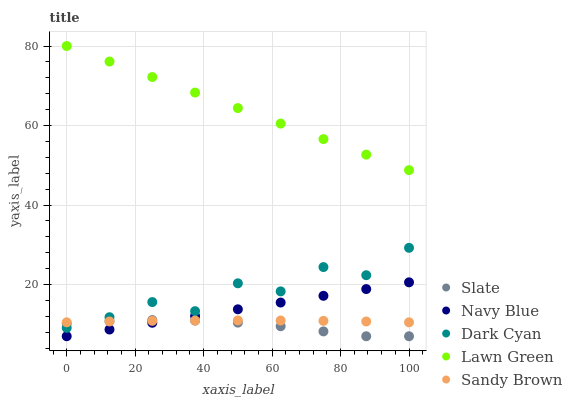Does Slate have the minimum area under the curve?
Answer yes or no. Yes. Does Lawn Green have the maximum area under the curve?
Answer yes or no. Yes. Does Navy Blue have the minimum area under the curve?
Answer yes or no. No. Does Navy Blue have the maximum area under the curve?
Answer yes or no. No. Is Navy Blue the smoothest?
Answer yes or no. Yes. Is Dark Cyan the roughest?
Answer yes or no. Yes. Is Slate the smoothest?
Answer yes or no. No. Is Slate the roughest?
Answer yes or no. No. Does Navy Blue have the lowest value?
Answer yes or no. Yes. Does Sandy Brown have the lowest value?
Answer yes or no. No. Does Lawn Green have the highest value?
Answer yes or no. Yes. Does Navy Blue have the highest value?
Answer yes or no. No. Is Dark Cyan less than Lawn Green?
Answer yes or no. Yes. Is Dark Cyan greater than Navy Blue?
Answer yes or no. Yes. Does Navy Blue intersect Slate?
Answer yes or no. Yes. Is Navy Blue less than Slate?
Answer yes or no. No. Is Navy Blue greater than Slate?
Answer yes or no. No. Does Dark Cyan intersect Lawn Green?
Answer yes or no. No. 